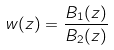<formula> <loc_0><loc_0><loc_500><loc_500>w ( z ) = \frac { B _ { 1 } ( z ) } { B _ { 2 } ( z ) }</formula> 